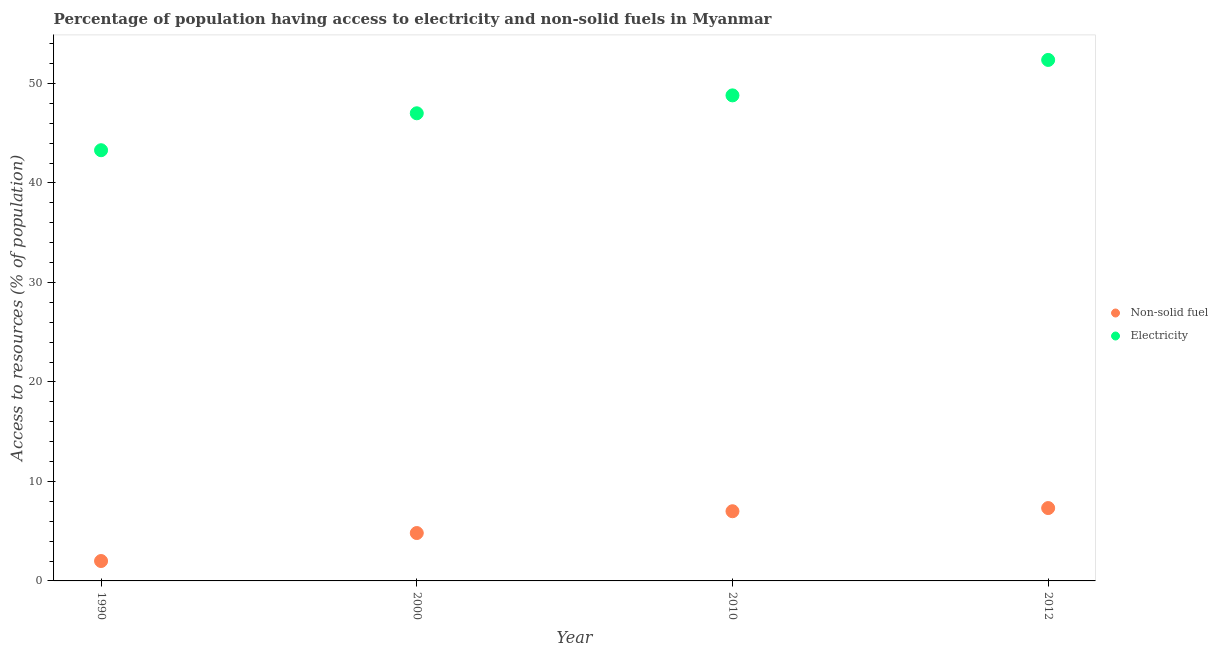How many different coloured dotlines are there?
Your response must be concise. 2. What is the percentage of population having access to non-solid fuel in 1990?
Your answer should be very brief. 2. Across all years, what is the maximum percentage of population having access to electricity?
Offer a very short reply. 52.36. Across all years, what is the minimum percentage of population having access to electricity?
Your response must be concise. 43.29. In which year was the percentage of population having access to non-solid fuel minimum?
Keep it short and to the point. 1990. What is the total percentage of population having access to non-solid fuel in the graph?
Offer a very short reply. 21.14. What is the difference between the percentage of population having access to non-solid fuel in 2000 and that in 2012?
Ensure brevity in your answer.  -2.51. What is the difference between the percentage of population having access to electricity in 2010 and the percentage of population having access to non-solid fuel in 2000?
Give a very brief answer. 43.99. What is the average percentage of population having access to non-solid fuel per year?
Your answer should be compact. 5.28. In the year 2000, what is the difference between the percentage of population having access to non-solid fuel and percentage of population having access to electricity?
Ensure brevity in your answer.  -42.19. What is the ratio of the percentage of population having access to electricity in 1990 to that in 2012?
Offer a terse response. 0.83. Is the difference between the percentage of population having access to electricity in 1990 and 2010 greater than the difference between the percentage of population having access to non-solid fuel in 1990 and 2010?
Provide a succinct answer. No. What is the difference between the highest and the second highest percentage of population having access to non-solid fuel?
Provide a short and direct response. 0.32. What is the difference between the highest and the lowest percentage of population having access to electricity?
Ensure brevity in your answer.  9.07. In how many years, is the percentage of population having access to electricity greater than the average percentage of population having access to electricity taken over all years?
Your answer should be very brief. 2. Is the percentage of population having access to electricity strictly less than the percentage of population having access to non-solid fuel over the years?
Offer a very short reply. No. How many dotlines are there?
Keep it short and to the point. 2. What is the difference between two consecutive major ticks on the Y-axis?
Offer a very short reply. 10. Are the values on the major ticks of Y-axis written in scientific E-notation?
Make the answer very short. No. Does the graph contain grids?
Keep it short and to the point. No. Where does the legend appear in the graph?
Ensure brevity in your answer.  Center right. How are the legend labels stacked?
Give a very brief answer. Vertical. What is the title of the graph?
Your answer should be very brief. Percentage of population having access to electricity and non-solid fuels in Myanmar. Does "Electricity" appear as one of the legend labels in the graph?
Offer a very short reply. Yes. What is the label or title of the X-axis?
Ensure brevity in your answer.  Year. What is the label or title of the Y-axis?
Offer a very short reply. Access to resources (% of population). What is the Access to resources (% of population) of Non-solid fuel in 1990?
Offer a very short reply. 2. What is the Access to resources (% of population) in Electricity in 1990?
Your response must be concise. 43.29. What is the Access to resources (% of population) in Non-solid fuel in 2000?
Make the answer very short. 4.81. What is the Access to resources (% of population) in Non-solid fuel in 2010?
Offer a very short reply. 7. What is the Access to resources (% of population) of Electricity in 2010?
Offer a terse response. 48.8. What is the Access to resources (% of population) of Non-solid fuel in 2012?
Ensure brevity in your answer.  7.32. What is the Access to resources (% of population) of Electricity in 2012?
Keep it short and to the point. 52.36. Across all years, what is the maximum Access to resources (% of population) of Non-solid fuel?
Provide a succinct answer. 7.32. Across all years, what is the maximum Access to resources (% of population) of Electricity?
Keep it short and to the point. 52.36. Across all years, what is the minimum Access to resources (% of population) in Non-solid fuel?
Your response must be concise. 2. Across all years, what is the minimum Access to resources (% of population) in Electricity?
Ensure brevity in your answer.  43.29. What is the total Access to resources (% of population) in Non-solid fuel in the graph?
Your answer should be very brief. 21.14. What is the total Access to resources (% of population) in Electricity in the graph?
Your answer should be very brief. 191.45. What is the difference between the Access to resources (% of population) in Non-solid fuel in 1990 and that in 2000?
Make the answer very short. -2.81. What is the difference between the Access to resources (% of population) of Electricity in 1990 and that in 2000?
Your answer should be very brief. -3.71. What is the difference between the Access to resources (% of population) in Non-solid fuel in 1990 and that in 2010?
Offer a very short reply. -5. What is the difference between the Access to resources (% of population) in Electricity in 1990 and that in 2010?
Offer a very short reply. -5.51. What is the difference between the Access to resources (% of population) in Non-solid fuel in 1990 and that in 2012?
Give a very brief answer. -5.32. What is the difference between the Access to resources (% of population) in Electricity in 1990 and that in 2012?
Offer a terse response. -9.07. What is the difference between the Access to resources (% of population) in Non-solid fuel in 2000 and that in 2010?
Offer a terse response. -2.19. What is the difference between the Access to resources (% of population) of Electricity in 2000 and that in 2010?
Your answer should be very brief. -1.8. What is the difference between the Access to resources (% of population) in Non-solid fuel in 2000 and that in 2012?
Your answer should be compact. -2.51. What is the difference between the Access to resources (% of population) of Electricity in 2000 and that in 2012?
Your answer should be very brief. -5.36. What is the difference between the Access to resources (% of population) in Non-solid fuel in 2010 and that in 2012?
Offer a terse response. -0.32. What is the difference between the Access to resources (% of population) of Electricity in 2010 and that in 2012?
Provide a succinct answer. -3.56. What is the difference between the Access to resources (% of population) of Non-solid fuel in 1990 and the Access to resources (% of population) of Electricity in 2000?
Ensure brevity in your answer.  -45. What is the difference between the Access to resources (% of population) of Non-solid fuel in 1990 and the Access to resources (% of population) of Electricity in 2010?
Your answer should be very brief. -46.8. What is the difference between the Access to resources (% of population) of Non-solid fuel in 1990 and the Access to resources (% of population) of Electricity in 2012?
Offer a terse response. -50.36. What is the difference between the Access to resources (% of population) in Non-solid fuel in 2000 and the Access to resources (% of population) in Electricity in 2010?
Your answer should be very brief. -43.99. What is the difference between the Access to resources (% of population) of Non-solid fuel in 2000 and the Access to resources (% of population) of Electricity in 2012?
Your answer should be compact. -47.55. What is the difference between the Access to resources (% of population) of Non-solid fuel in 2010 and the Access to resources (% of population) of Electricity in 2012?
Offer a terse response. -45.36. What is the average Access to resources (% of population) of Non-solid fuel per year?
Offer a very short reply. 5.28. What is the average Access to resources (% of population) in Electricity per year?
Provide a succinct answer. 47.86. In the year 1990, what is the difference between the Access to resources (% of population) in Non-solid fuel and Access to resources (% of population) in Electricity?
Provide a succinct answer. -41.29. In the year 2000, what is the difference between the Access to resources (% of population) in Non-solid fuel and Access to resources (% of population) in Electricity?
Your answer should be compact. -42.19. In the year 2010, what is the difference between the Access to resources (% of population) of Non-solid fuel and Access to resources (% of population) of Electricity?
Give a very brief answer. -41.8. In the year 2012, what is the difference between the Access to resources (% of population) of Non-solid fuel and Access to resources (% of population) of Electricity?
Your answer should be compact. -45.04. What is the ratio of the Access to resources (% of population) in Non-solid fuel in 1990 to that in 2000?
Provide a short and direct response. 0.42. What is the ratio of the Access to resources (% of population) of Electricity in 1990 to that in 2000?
Your answer should be compact. 0.92. What is the ratio of the Access to resources (% of population) in Non-solid fuel in 1990 to that in 2010?
Ensure brevity in your answer.  0.29. What is the ratio of the Access to resources (% of population) of Electricity in 1990 to that in 2010?
Your answer should be very brief. 0.89. What is the ratio of the Access to resources (% of population) of Non-solid fuel in 1990 to that in 2012?
Give a very brief answer. 0.27. What is the ratio of the Access to resources (% of population) of Electricity in 1990 to that in 2012?
Keep it short and to the point. 0.83. What is the ratio of the Access to resources (% of population) in Non-solid fuel in 2000 to that in 2010?
Offer a very short reply. 0.69. What is the ratio of the Access to resources (% of population) in Electricity in 2000 to that in 2010?
Provide a short and direct response. 0.96. What is the ratio of the Access to resources (% of population) of Non-solid fuel in 2000 to that in 2012?
Give a very brief answer. 0.66. What is the ratio of the Access to resources (% of population) in Electricity in 2000 to that in 2012?
Your answer should be very brief. 0.9. What is the ratio of the Access to resources (% of population) in Non-solid fuel in 2010 to that in 2012?
Provide a short and direct response. 0.96. What is the ratio of the Access to resources (% of population) of Electricity in 2010 to that in 2012?
Make the answer very short. 0.93. What is the difference between the highest and the second highest Access to resources (% of population) of Non-solid fuel?
Give a very brief answer. 0.32. What is the difference between the highest and the second highest Access to resources (% of population) in Electricity?
Give a very brief answer. 3.56. What is the difference between the highest and the lowest Access to resources (% of population) in Non-solid fuel?
Your answer should be compact. 5.32. What is the difference between the highest and the lowest Access to resources (% of population) in Electricity?
Offer a very short reply. 9.07. 